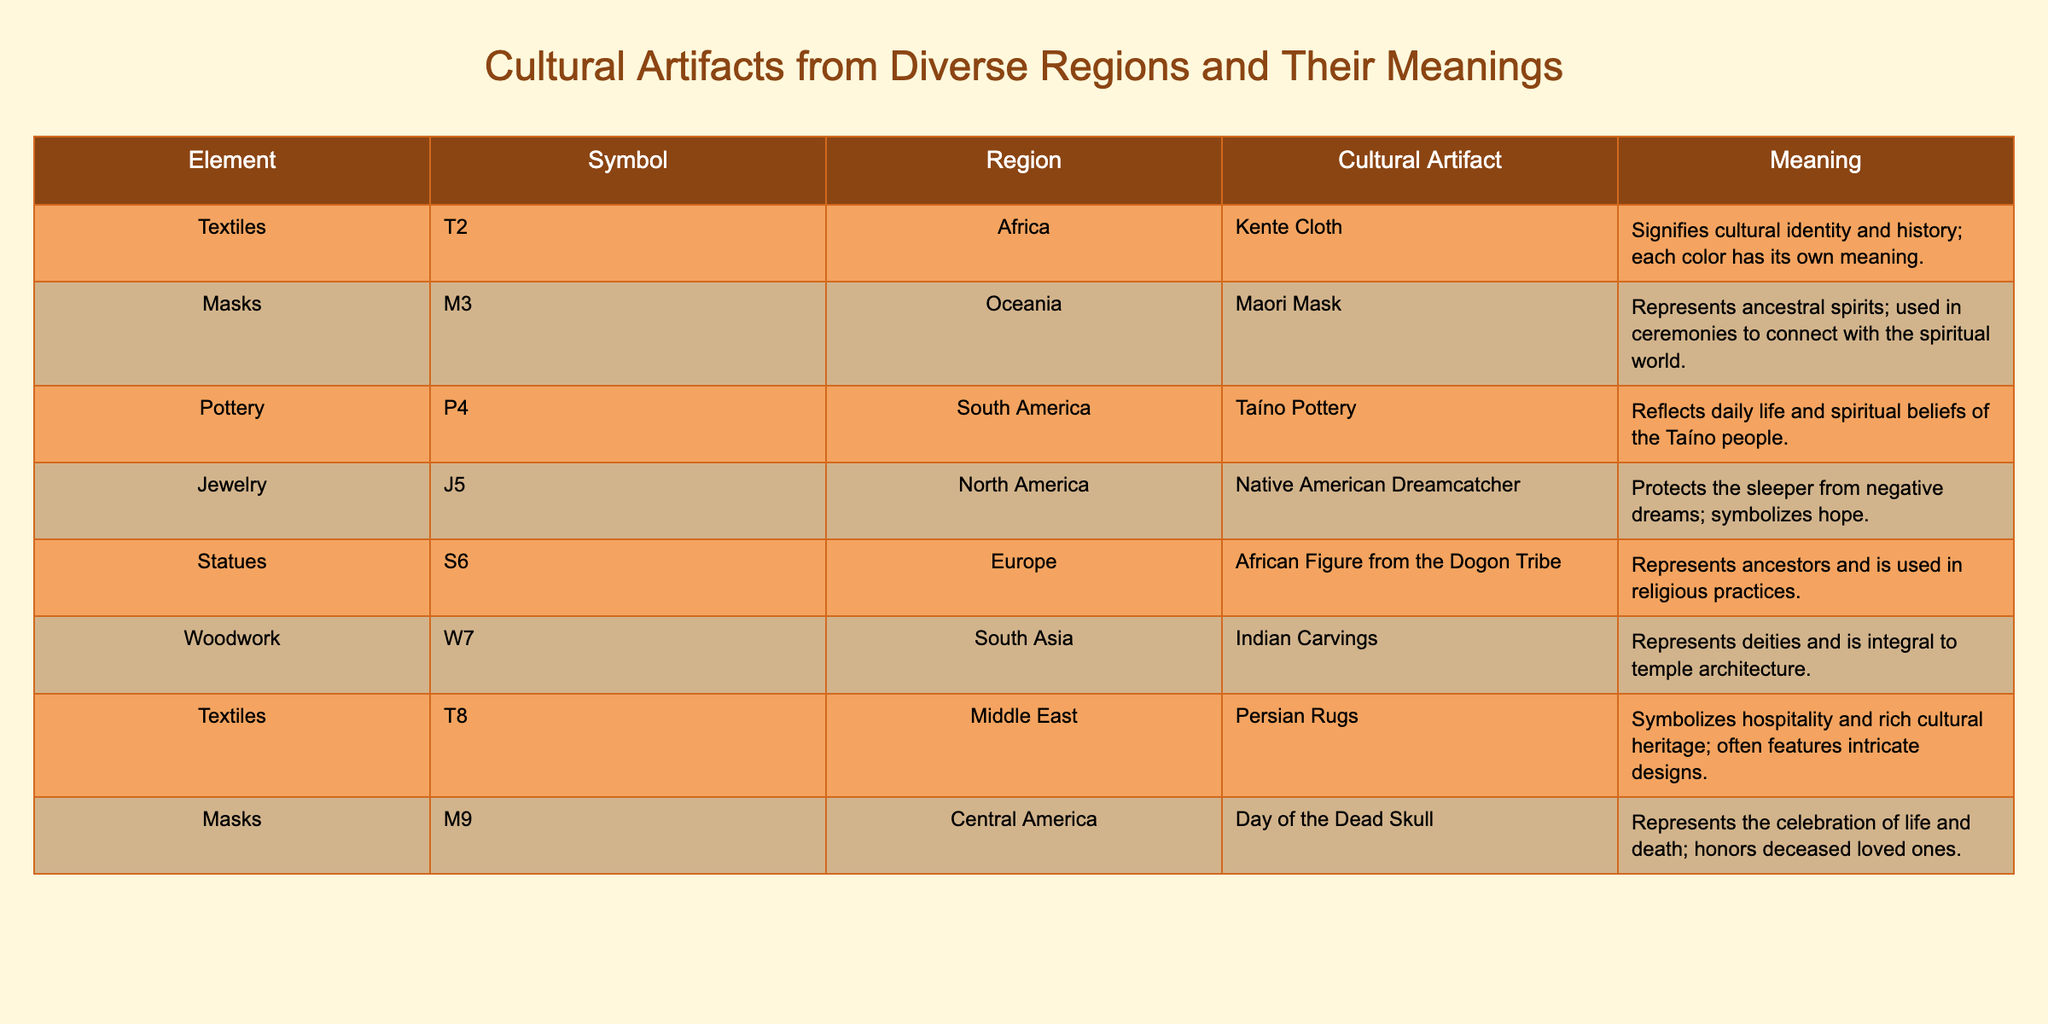What does Kente Cloth signify? Kente Cloth, a cultural artifact from Africa, is noted in the table as signifying cultural identity and history. This meaning is directly stated in the table.
Answer: Cultural identity and history Which artifact is associated with the celebration of life and death? The artifact related to the celebration of life and death, according to the table, is the Day of the Dead Skull from Central America. This information can be directly retrieved from the table.
Answer: Day of the Dead Skull How many regions are represented by cultural artifacts in the table? The table contains cultural artifacts from eight distinct regions: Africa, Oceania, South America, North America, Europe, South Asia, Middle East, and Central America. Counting each of these regions gives a total of eight.
Answer: 8 Are Persian Rugs associated with hospitality? Yes, the table states that Persian Rugs symbolize hospitality among other meanings, confirming that this statement is true.
Answer: Yes Which cultural artifact represents ancestors and is used in religious practices? The African Figure from the Dogon Tribe, as indicated in the table, represents ancestors and is employed in religious practices. This information is directly available in the table.
Answer: African Figure from the Dogon Tribe What is the average meaning associated with textiles from different regions? The meanings for textiles listed in the table include: Kente Cloth, which signifies cultural identity, and Persian Rugs, which symbolize hospitality. To find the 'average' meaning is subjective, but they both convey significant cultural values related to identity and heritage, showing the importance of textiles in cultural representation.
Answer: Significant cultural values Which regions have artifacts that relate to spirituality? The regions with artifacts that connect to spirituality, as identified in the table, are Oceania (Maori Mask), South America (Taíno Pottery), and South Asia (Indian Carvings). This requires checking each region and identifying which artifacts relate to spiritual beliefs or practices.
Answer: Oceania, South America, South Asia What is the total number of artifacts listed in the table? The table lists a total of eight artifacts, each corresponding to a distinct cultural expression from various regions. Counting these entries reveals the total number.
Answer: 8 Does the Native American Dreamcatcher symbolize hope? Yes, the table confirms that the Native American Dreamcatcher is meant to protect the sleeper from negative dreams and symbolizes hope, making this statement true.
Answer: Yes 